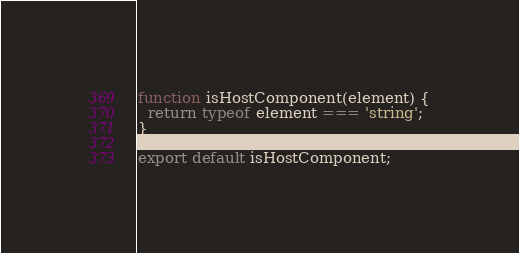<code> <loc_0><loc_0><loc_500><loc_500><_JavaScript_>function isHostComponent(element) {
  return typeof element === 'string';
}

export default isHostComponent;
</code> 